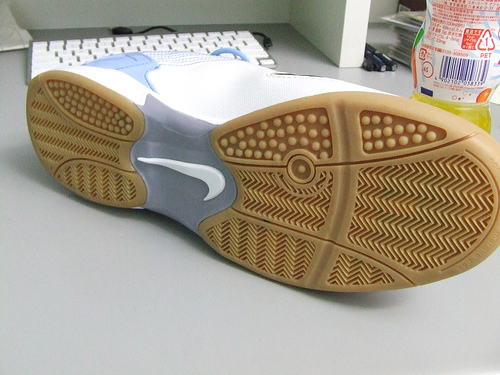<image>
Is there a nike logo on the shoe bottom? Yes. Looking at the image, I can see the nike logo is positioned on top of the shoe bottom, with the shoe bottom providing support. 